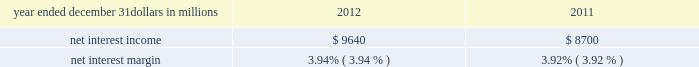Consolidated income statement review our consolidated income statement is presented in item 8 of this report .
Net income for 2012 was $ 3.0 billion compared with $ 3.1 billion for 2011 .
Revenue growth of 8 percent and a decline in the provision for credit losses were more than offset by a 16 percent increase in noninterest expense in 2012 compared to 2011 .
Further detail is included in the net interest income , noninterest income , provision for credit losses and noninterest expense portions of this consolidated income statement review .
Net interest income table 2 : net interest income and net interest margin year ended december 31 dollars in millions 2012 2011 .
Changes in net interest income and margin result from the interaction of the volume and composition of interest-earning assets and related yields , interest-bearing liabilities and related rates paid , and noninterest-bearing sources of funding .
See the statistical information ( unaudited ) 2013 average consolidated balance sheet and net interest analysis and analysis of year-to-year changes in net interest income in item 8 of this report and the discussion of purchase accounting accretion of purchased impaired loans in the consolidated balance sheet review in this item 7 for additional information .
The increase in net interest income in 2012 compared with 2011 was primarily due to the impact of the rbc bank ( usa ) acquisition , organic loan growth and lower funding costs .
Purchase accounting accretion remained stable at $ 1.1 billion in both periods .
The net interest margin was 3.94% ( 3.94 % ) for 2012 and 3.92% ( 3.92 % ) for 2011 .
The increase in the comparison was primarily due to a decrease in the weighted-average rate accrued on total interest- bearing liabilities of 29 basis points , largely offset by a 21 basis point decrease on the yield on total interest-earning assets .
The decrease in the rate on interest-bearing liabilities was primarily due to the runoff of maturing retail certificates of deposit and the redemption of additional trust preferred and hybrid capital securities during 2012 , in addition to an increase in fhlb borrowings and commercial paper as lower-cost funding sources .
The decrease in the yield on interest-earning assets was primarily due to lower rates on new loan volume and lower yields on new securities in the current low rate environment .
With respect to the first quarter of 2013 , we expect net interest income to decline by two to three percent compared to fourth quarter 2012 net interest income of $ 2.4 billion , due to a decrease in purchase accounting accretion of up to $ 50 to $ 60 million , including lower expected cash recoveries .
For the full year 2013 , we expect net interest income to decrease compared with 2012 , assuming an expected decline in purchase accounting accretion of approximately $ 400 million , while core net interest income is expected to increase in the year-over-year comparison .
We believe our net interest margin will come under pressure in 2013 , due to the expected decline in purchase accounting accretion and assuming that the current low rate environment continues .
Noninterest income noninterest income totaled $ 5.9 billion for 2012 and $ 5.6 billion for 2011 .
The overall increase in the comparison was primarily due to an increase in residential mortgage loan sales revenue driven by higher loan origination volume , gains on sales of visa class b common shares and higher corporate service fees , largely offset by higher provision for residential mortgage repurchase obligations .
Asset management revenue , including blackrock , totaled $ 1.2 billion in 2012 compared with $ 1.1 billion in 2011 .
This increase was primarily due to higher earnings from our blackrock investment .
Discretionary assets under management increased to $ 112 billion at december 31 , 2012 compared with $ 107 billion at december 31 , 2011 driven by stronger average equity markets , positive net flows and strong sales performance .
For 2012 , consumer services fees were $ 1.1 billion compared with $ 1.2 billion in 2011 .
The decline reflected the regulatory impact of lower interchange fees on debit card transactions partially offset by customer growth .
As further discussed in the retail banking portion of the business segments review section of this item 7 , the dodd-frank limits on interchange rates were effective october 1 , 2011 and had a negative impact on revenue of approximately $ 314 million in 2012 and $ 75 million in 2011 .
This impact was partially offset by higher volumes of merchant , customer credit card and debit card transactions and the impact of the rbc bank ( usa ) acquisition .
Corporate services revenue increased by $ .3 billion , or 30 percent , to $ 1.2 billion in 2012 compared with $ .9 billion in 2011 due to higher commercial mortgage servicing revenue and higher merger and acquisition advisory fees in 2012 .
The major components of corporate services revenue are treasury management revenue , corporate finance fees , including revenue from capital markets-related products and services , and commercial mortgage servicing revenue , including commercial mortgage banking activities .
See the product revenue portion of this consolidated income statement review for further detail .
The pnc financial services group , inc .
2013 form 10-k 39 .
What was the change in net interest margin between 2012 and 2011.? 
Computations: (3.94 - 3.92)
Answer: 0.02. 